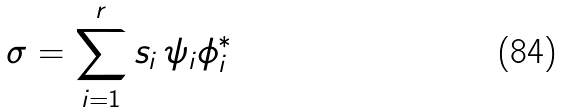<formula> <loc_0><loc_0><loc_500><loc_500>\sigma = \sum _ { i = 1 } ^ { r } s _ { i } \, \psi _ { i } \phi _ { i } ^ { * }</formula> 